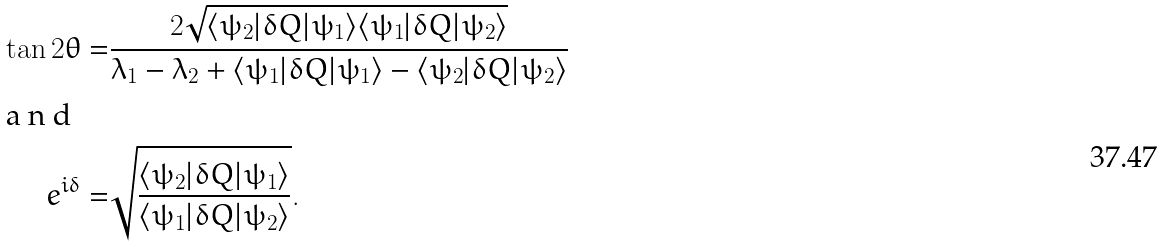<formula> <loc_0><loc_0><loc_500><loc_500>\tan 2 \theta = & \frac { 2 \sqrt { \langle \psi _ { 2 } | \delta Q | \psi _ { 1 } \rangle \langle \psi _ { 1 } | \delta Q | \psi _ { 2 } \rangle } } { \lambda _ { 1 } - \lambda _ { 2 } + \langle \psi _ { 1 } | \delta Q | \psi _ { 1 } \rangle - \langle \psi _ { 2 } | \delta Q | \psi _ { 2 } \rangle } \\ \intertext { a n d } e ^ { i \delta } = & \sqrt { \frac { \langle \psi _ { 2 } | \delta Q | \psi _ { 1 } \rangle } { \langle \psi _ { 1 } | \delta Q | \psi _ { 2 } \rangle } } .</formula> 